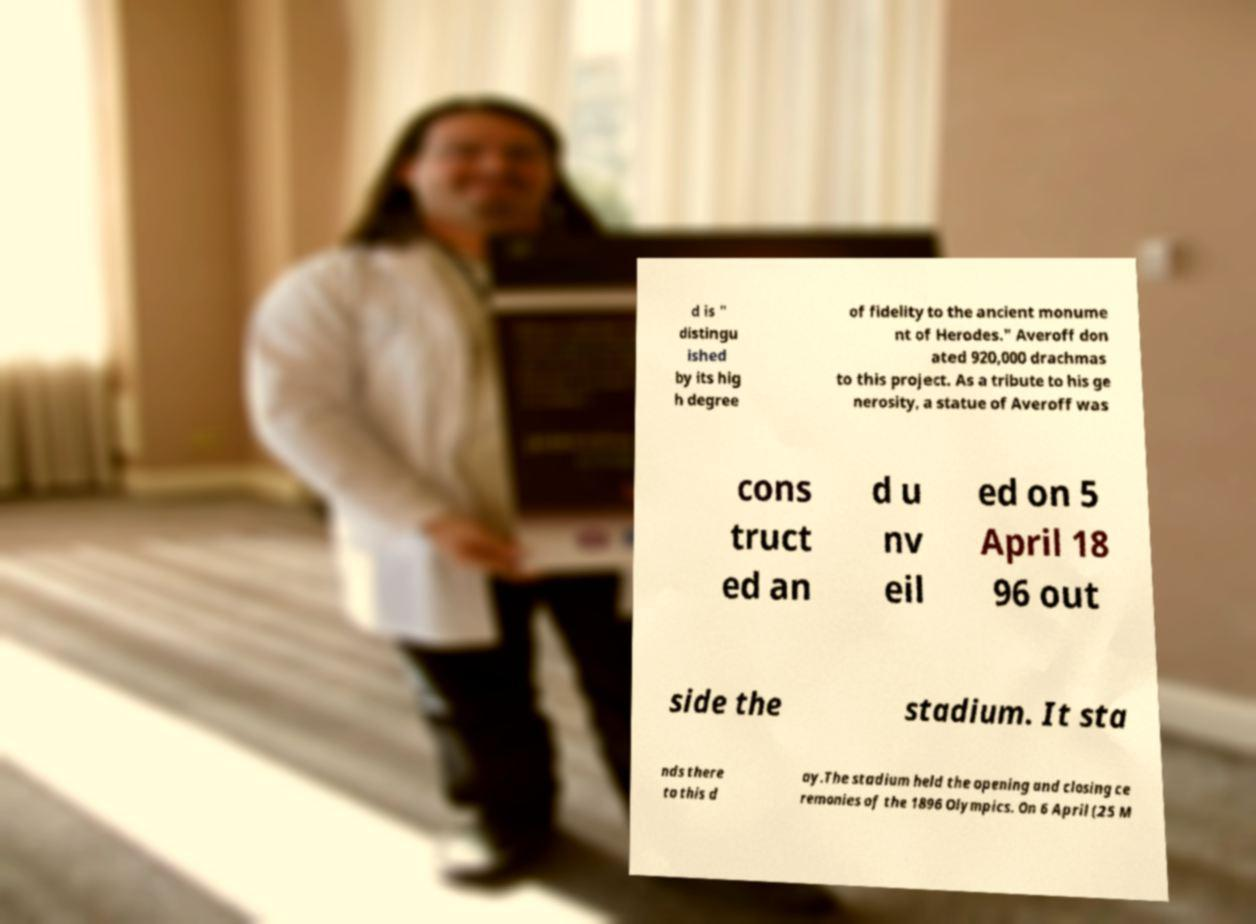Can you accurately transcribe the text from the provided image for me? d is " distingu ished by its hig h degree of fidelity to the ancient monume nt of Herodes." Averoff don ated 920,000 drachmas to this project. As a tribute to his ge nerosity, a statue of Averoff was cons truct ed an d u nv eil ed on 5 April 18 96 out side the stadium. It sta nds there to this d ay.The stadium held the opening and closing ce remonies of the 1896 Olympics. On 6 April (25 M 